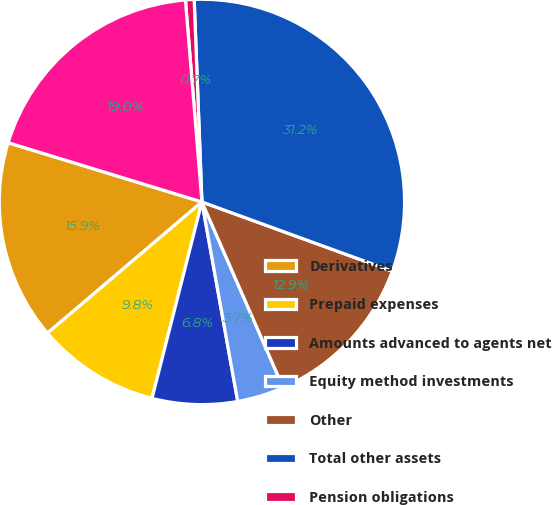<chart> <loc_0><loc_0><loc_500><loc_500><pie_chart><fcel>Derivatives<fcel>Prepaid expenses<fcel>Amounts advanced to agents net<fcel>Equity method investments<fcel>Other<fcel>Total other assets<fcel>Pension obligations<fcel>Total other liabilities<nl><fcel>15.93%<fcel>9.83%<fcel>6.79%<fcel>3.74%<fcel>12.88%<fcel>31.16%<fcel>0.69%<fcel>18.98%<nl></chart> 